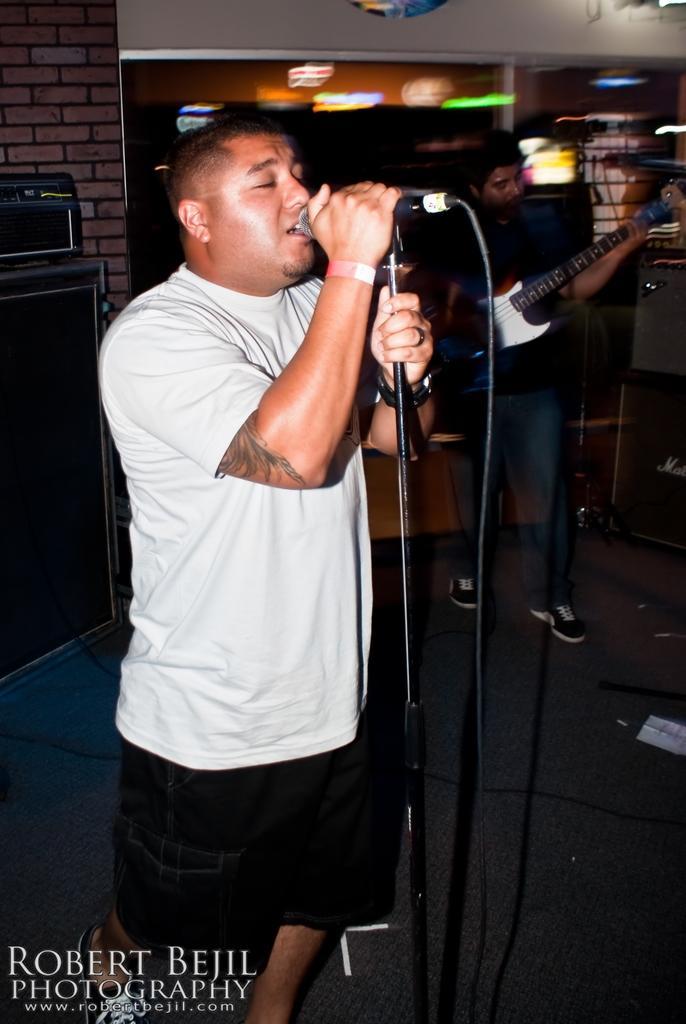Can you describe this image briefly? In this image two persons are standing. One person is wearing a white shirt is holding a mike stand. Another person is holding a guitar is wearing shoes. 